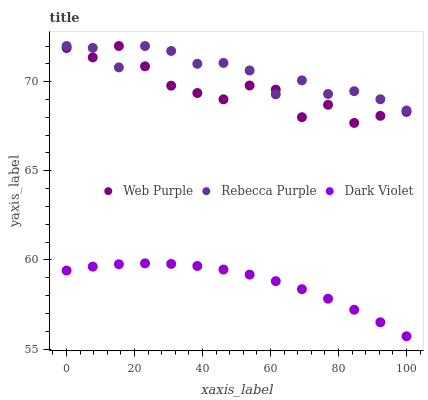Does Dark Violet have the minimum area under the curve?
Answer yes or no. Yes. Does Rebecca Purple have the maximum area under the curve?
Answer yes or no. Yes. Does Rebecca Purple have the minimum area under the curve?
Answer yes or no. No. Does Dark Violet have the maximum area under the curve?
Answer yes or no. No. Is Dark Violet the smoothest?
Answer yes or no. Yes. Is Web Purple the roughest?
Answer yes or no. Yes. Is Rebecca Purple the smoothest?
Answer yes or no. No. Is Rebecca Purple the roughest?
Answer yes or no. No. Does Dark Violet have the lowest value?
Answer yes or no. Yes. Does Rebecca Purple have the lowest value?
Answer yes or no. No. Does Rebecca Purple have the highest value?
Answer yes or no. Yes. Does Dark Violet have the highest value?
Answer yes or no. No. Is Dark Violet less than Web Purple?
Answer yes or no. Yes. Is Web Purple greater than Dark Violet?
Answer yes or no. Yes. Does Rebecca Purple intersect Web Purple?
Answer yes or no. Yes. Is Rebecca Purple less than Web Purple?
Answer yes or no. No. Is Rebecca Purple greater than Web Purple?
Answer yes or no. No. Does Dark Violet intersect Web Purple?
Answer yes or no. No. 